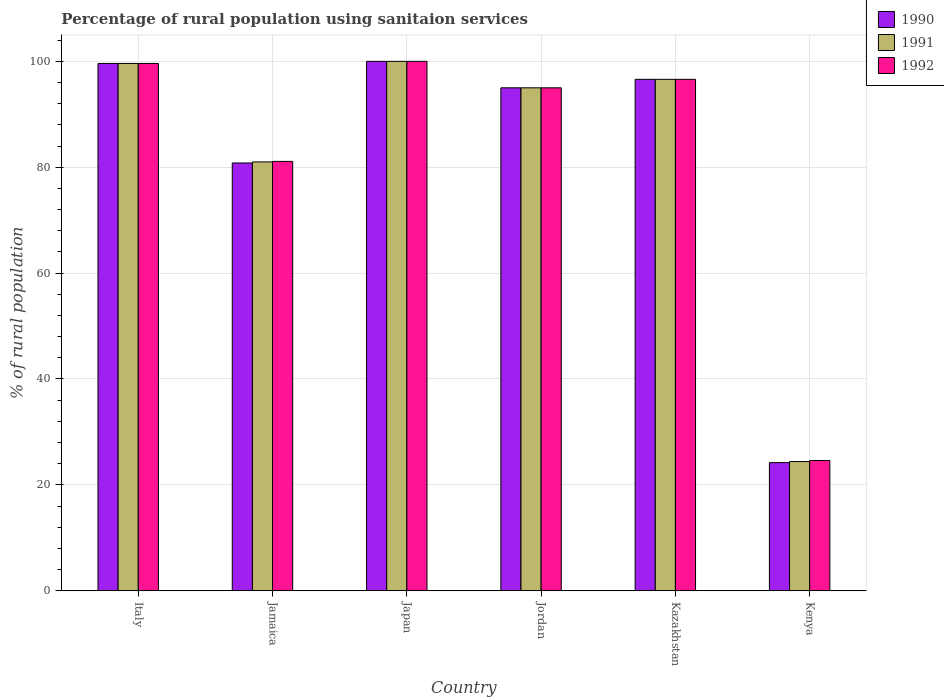How many different coloured bars are there?
Your response must be concise. 3. Are the number of bars per tick equal to the number of legend labels?
Provide a succinct answer. Yes. How many bars are there on the 4th tick from the left?
Your response must be concise. 3. How many bars are there on the 3rd tick from the right?
Provide a short and direct response. 3. What is the label of the 5th group of bars from the left?
Make the answer very short. Kazakhstan. In how many cases, is the number of bars for a given country not equal to the number of legend labels?
Ensure brevity in your answer.  0. What is the percentage of rural population using sanitaion services in 1991 in Kazakhstan?
Offer a very short reply. 96.6. Across all countries, what is the maximum percentage of rural population using sanitaion services in 1990?
Your answer should be very brief. 100. Across all countries, what is the minimum percentage of rural population using sanitaion services in 1991?
Offer a very short reply. 24.4. In which country was the percentage of rural population using sanitaion services in 1991 minimum?
Ensure brevity in your answer.  Kenya. What is the total percentage of rural population using sanitaion services in 1990 in the graph?
Offer a very short reply. 496.2. What is the difference between the percentage of rural population using sanitaion services in 1992 in Jordan and that in Kenya?
Offer a very short reply. 70.4. What is the difference between the percentage of rural population using sanitaion services in 1992 in Italy and the percentage of rural population using sanitaion services in 1990 in Japan?
Keep it short and to the point. -0.4. What is the average percentage of rural population using sanitaion services in 1990 per country?
Your answer should be compact. 82.7. What is the difference between the percentage of rural population using sanitaion services of/in 1991 and percentage of rural population using sanitaion services of/in 1990 in Japan?
Your answer should be very brief. 0. What is the ratio of the percentage of rural population using sanitaion services in 1990 in Italy to that in Kenya?
Offer a terse response. 4.12. What is the difference between the highest and the second highest percentage of rural population using sanitaion services in 1992?
Offer a very short reply. -3. What is the difference between the highest and the lowest percentage of rural population using sanitaion services in 1990?
Ensure brevity in your answer.  75.8. Is the sum of the percentage of rural population using sanitaion services in 1990 in Japan and Kazakhstan greater than the maximum percentage of rural population using sanitaion services in 1991 across all countries?
Keep it short and to the point. Yes. What does the 2nd bar from the left in Jamaica represents?
Keep it short and to the point. 1991. How many bars are there?
Provide a short and direct response. 18. Are all the bars in the graph horizontal?
Provide a short and direct response. No. What is the difference between two consecutive major ticks on the Y-axis?
Your answer should be compact. 20. Does the graph contain any zero values?
Make the answer very short. No. Where does the legend appear in the graph?
Your response must be concise. Top right. What is the title of the graph?
Make the answer very short. Percentage of rural population using sanitaion services. What is the label or title of the X-axis?
Your answer should be very brief. Country. What is the label or title of the Y-axis?
Make the answer very short. % of rural population. What is the % of rural population in 1990 in Italy?
Give a very brief answer. 99.6. What is the % of rural population in 1991 in Italy?
Keep it short and to the point. 99.6. What is the % of rural population of 1992 in Italy?
Provide a short and direct response. 99.6. What is the % of rural population of 1990 in Jamaica?
Offer a terse response. 80.8. What is the % of rural population in 1991 in Jamaica?
Your answer should be very brief. 81. What is the % of rural population in 1992 in Jamaica?
Your answer should be very brief. 81.1. What is the % of rural population in 1991 in Japan?
Your response must be concise. 100. What is the % of rural population in 1991 in Jordan?
Keep it short and to the point. 95. What is the % of rural population in 1990 in Kazakhstan?
Your answer should be compact. 96.6. What is the % of rural population in 1991 in Kazakhstan?
Keep it short and to the point. 96.6. What is the % of rural population in 1992 in Kazakhstan?
Make the answer very short. 96.6. What is the % of rural population of 1990 in Kenya?
Ensure brevity in your answer.  24.2. What is the % of rural population of 1991 in Kenya?
Make the answer very short. 24.4. What is the % of rural population in 1992 in Kenya?
Make the answer very short. 24.6. Across all countries, what is the maximum % of rural population of 1991?
Provide a short and direct response. 100. Across all countries, what is the minimum % of rural population in 1990?
Make the answer very short. 24.2. Across all countries, what is the minimum % of rural population of 1991?
Make the answer very short. 24.4. Across all countries, what is the minimum % of rural population in 1992?
Keep it short and to the point. 24.6. What is the total % of rural population in 1990 in the graph?
Offer a terse response. 496.2. What is the total % of rural population of 1991 in the graph?
Give a very brief answer. 496.6. What is the total % of rural population in 1992 in the graph?
Keep it short and to the point. 496.9. What is the difference between the % of rural population of 1991 in Italy and that in Jamaica?
Your answer should be very brief. 18.6. What is the difference between the % of rural population in 1991 in Italy and that in Japan?
Your response must be concise. -0.4. What is the difference between the % of rural population of 1992 in Italy and that in Japan?
Offer a very short reply. -0.4. What is the difference between the % of rural population of 1992 in Italy and that in Jordan?
Ensure brevity in your answer.  4.6. What is the difference between the % of rural population in 1992 in Italy and that in Kazakhstan?
Provide a short and direct response. 3. What is the difference between the % of rural population of 1990 in Italy and that in Kenya?
Your answer should be very brief. 75.4. What is the difference between the % of rural population of 1991 in Italy and that in Kenya?
Ensure brevity in your answer.  75.2. What is the difference between the % of rural population in 1990 in Jamaica and that in Japan?
Offer a terse response. -19.2. What is the difference between the % of rural population in 1991 in Jamaica and that in Japan?
Provide a succinct answer. -19. What is the difference between the % of rural population in 1992 in Jamaica and that in Japan?
Provide a short and direct response. -18.9. What is the difference between the % of rural population in 1990 in Jamaica and that in Kazakhstan?
Your answer should be compact. -15.8. What is the difference between the % of rural population of 1991 in Jamaica and that in Kazakhstan?
Your answer should be compact. -15.6. What is the difference between the % of rural population in 1992 in Jamaica and that in Kazakhstan?
Make the answer very short. -15.5. What is the difference between the % of rural population in 1990 in Jamaica and that in Kenya?
Keep it short and to the point. 56.6. What is the difference between the % of rural population of 1991 in Jamaica and that in Kenya?
Give a very brief answer. 56.6. What is the difference between the % of rural population of 1992 in Jamaica and that in Kenya?
Your answer should be compact. 56.5. What is the difference between the % of rural population in 1990 in Japan and that in Jordan?
Make the answer very short. 5. What is the difference between the % of rural population of 1992 in Japan and that in Jordan?
Offer a terse response. 5. What is the difference between the % of rural population in 1991 in Japan and that in Kazakhstan?
Give a very brief answer. 3.4. What is the difference between the % of rural population in 1990 in Japan and that in Kenya?
Your response must be concise. 75.8. What is the difference between the % of rural population in 1991 in Japan and that in Kenya?
Keep it short and to the point. 75.6. What is the difference between the % of rural population of 1992 in Japan and that in Kenya?
Provide a succinct answer. 75.4. What is the difference between the % of rural population of 1990 in Jordan and that in Kazakhstan?
Provide a succinct answer. -1.6. What is the difference between the % of rural population in 1991 in Jordan and that in Kazakhstan?
Offer a terse response. -1.6. What is the difference between the % of rural population in 1990 in Jordan and that in Kenya?
Provide a succinct answer. 70.8. What is the difference between the % of rural population of 1991 in Jordan and that in Kenya?
Provide a succinct answer. 70.6. What is the difference between the % of rural population in 1992 in Jordan and that in Kenya?
Ensure brevity in your answer.  70.4. What is the difference between the % of rural population of 1990 in Kazakhstan and that in Kenya?
Offer a terse response. 72.4. What is the difference between the % of rural population in 1991 in Kazakhstan and that in Kenya?
Keep it short and to the point. 72.2. What is the difference between the % of rural population in 1990 in Italy and the % of rural population in 1991 in Jamaica?
Your answer should be compact. 18.6. What is the difference between the % of rural population in 1990 in Italy and the % of rural population in 1992 in Jamaica?
Offer a terse response. 18.5. What is the difference between the % of rural population of 1990 in Italy and the % of rural population of 1991 in Japan?
Ensure brevity in your answer.  -0.4. What is the difference between the % of rural population in 1990 in Italy and the % of rural population in 1991 in Jordan?
Ensure brevity in your answer.  4.6. What is the difference between the % of rural population of 1990 in Italy and the % of rural population of 1992 in Jordan?
Give a very brief answer. 4.6. What is the difference between the % of rural population of 1990 in Italy and the % of rural population of 1991 in Kazakhstan?
Your answer should be compact. 3. What is the difference between the % of rural population in 1990 in Italy and the % of rural population in 1991 in Kenya?
Your answer should be very brief. 75.2. What is the difference between the % of rural population of 1990 in Jamaica and the % of rural population of 1991 in Japan?
Make the answer very short. -19.2. What is the difference between the % of rural population of 1990 in Jamaica and the % of rural population of 1992 in Japan?
Your response must be concise. -19.2. What is the difference between the % of rural population in 1990 in Jamaica and the % of rural population in 1991 in Jordan?
Your response must be concise. -14.2. What is the difference between the % of rural population in 1990 in Jamaica and the % of rural population in 1992 in Jordan?
Ensure brevity in your answer.  -14.2. What is the difference between the % of rural population of 1991 in Jamaica and the % of rural population of 1992 in Jordan?
Your answer should be very brief. -14. What is the difference between the % of rural population in 1990 in Jamaica and the % of rural population in 1991 in Kazakhstan?
Provide a succinct answer. -15.8. What is the difference between the % of rural population in 1990 in Jamaica and the % of rural population in 1992 in Kazakhstan?
Offer a very short reply. -15.8. What is the difference between the % of rural population in 1991 in Jamaica and the % of rural population in 1992 in Kazakhstan?
Provide a short and direct response. -15.6. What is the difference between the % of rural population of 1990 in Jamaica and the % of rural population of 1991 in Kenya?
Provide a succinct answer. 56.4. What is the difference between the % of rural population of 1990 in Jamaica and the % of rural population of 1992 in Kenya?
Your response must be concise. 56.2. What is the difference between the % of rural population of 1991 in Jamaica and the % of rural population of 1992 in Kenya?
Keep it short and to the point. 56.4. What is the difference between the % of rural population in 1990 in Japan and the % of rural population in 1992 in Jordan?
Your answer should be compact. 5. What is the difference between the % of rural population of 1990 in Japan and the % of rural population of 1992 in Kazakhstan?
Provide a succinct answer. 3.4. What is the difference between the % of rural population of 1990 in Japan and the % of rural population of 1991 in Kenya?
Ensure brevity in your answer.  75.6. What is the difference between the % of rural population in 1990 in Japan and the % of rural population in 1992 in Kenya?
Your response must be concise. 75.4. What is the difference between the % of rural population of 1991 in Japan and the % of rural population of 1992 in Kenya?
Give a very brief answer. 75.4. What is the difference between the % of rural population in 1990 in Jordan and the % of rural population in 1991 in Kazakhstan?
Offer a very short reply. -1.6. What is the difference between the % of rural population of 1990 in Jordan and the % of rural population of 1992 in Kazakhstan?
Make the answer very short. -1.6. What is the difference between the % of rural population of 1990 in Jordan and the % of rural population of 1991 in Kenya?
Provide a short and direct response. 70.6. What is the difference between the % of rural population of 1990 in Jordan and the % of rural population of 1992 in Kenya?
Keep it short and to the point. 70.4. What is the difference between the % of rural population of 1991 in Jordan and the % of rural population of 1992 in Kenya?
Provide a short and direct response. 70.4. What is the difference between the % of rural population of 1990 in Kazakhstan and the % of rural population of 1991 in Kenya?
Provide a succinct answer. 72.2. What is the difference between the % of rural population of 1990 in Kazakhstan and the % of rural population of 1992 in Kenya?
Ensure brevity in your answer.  72. What is the average % of rural population of 1990 per country?
Your response must be concise. 82.7. What is the average % of rural population in 1991 per country?
Your answer should be very brief. 82.77. What is the average % of rural population of 1992 per country?
Offer a very short reply. 82.82. What is the difference between the % of rural population of 1990 and % of rural population of 1991 in Italy?
Offer a very short reply. 0. What is the difference between the % of rural population in 1990 and % of rural population in 1992 in Jamaica?
Offer a very short reply. -0.3. What is the difference between the % of rural population of 1991 and % of rural population of 1992 in Jamaica?
Your response must be concise. -0.1. What is the difference between the % of rural population in 1990 and % of rural population in 1991 in Japan?
Your answer should be compact. 0. What is the difference between the % of rural population in 1990 and % of rural population in 1991 in Jordan?
Keep it short and to the point. 0. What is the difference between the % of rural population of 1990 and % of rural population of 1991 in Kazakhstan?
Ensure brevity in your answer.  0. What is the difference between the % of rural population in 1990 and % of rural population in 1991 in Kenya?
Ensure brevity in your answer.  -0.2. What is the difference between the % of rural population of 1990 and % of rural population of 1992 in Kenya?
Your response must be concise. -0.4. What is the difference between the % of rural population in 1991 and % of rural population in 1992 in Kenya?
Make the answer very short. -0.2. What is the ratio of the % of rural population of 1990 in Italy to that in Jamaica?
Make the answer very short. 1.23. What is the ratio of the % of rural population in 1991 in Italy to that in Jamaica?
Keep it short and to the point. 1.23. What is the ratio of the % of rural population of 1992 in Italy to that in Jamaica?
Keep it short and to the point. 1.23. What is the ratio of the % of rural population of 1990 in Italy to that in Jordan?
Your answer should be very brief. 1.05. What is the ratio of the % of rural population of 1991 in Italy to that in Jordan?
Offer a terse response. 1.05. What is the ratio of the % of rural population of 1992 in Italy to that in Jordan?
Give a very brief answer. 1.05. What is the ratio of the % of rural population in 1990 in Italy to that in Kazakhstan?
Keep it short and to the point. 1.03. What is the ratio of the % of rural population of 1991 in Italy to that in Kazakhstan?
Offer a very short reply. 1.03. What is the ratio of the % of rural population in 1992 in Italy to that in Kazakhstan?
Keep it short and to the point. 1.03. What is the ratio of the % of rural population of 1990 in Italy to that in Kenya?
Offer a terse response. 4.12. What is the ratio of the % of rural population of 1991 in Italy to that in Kenya?
Keep it short and to the point. 4.08. What is the ratio of the % of rural population in 1992 in Italy to that in Kenya?
Ensure brevity in your answer.  4.05. What is the ratio of the % of rural population of 1990 in Jamaica to that in Japan?
Provide a short and direct response. 0.81. What is the ratio of the % of rural population of 1991 in Jamaica to that in Japan?
Offer a terse response. 0.81. What is the ratio of the % of rural population in 1992 in Jamaica to that in Japan?
Your answer should be compact. 0.81. What is the ratio of the % of rural population in 1990 in Jamaica to that in Jordan?
Make the answer very short. 0.85. What is the ratio of the % of rural population of 1991 in Jamaica to that in Jordan?
Make the answer very short. 0.85. What is the ratio of the % of rural population in 1992 in Jamaica to that in Jordan?
Make the answer very short. 0.85. What is the ratio of the % of rural population in 1990 in Jamaica to that in Kazakhstan?
Make the answer very short. 0.84. What is the ratio of the % of rural population in 1991 in Jamaica to that in Kazakhstan?
Your response must be concise. 0.84. What is the ratio of the % of rural population of 1992 in Jamaica to that in Kazakhstan?
Give a very brief answer. 0.84. What is the ratio of the % of rural population in 1990 in Jamaica to that in Kenya?
Provide a short and direct response. 3.34. What is the ratio of the % of rural population in 1991 in Jamaica to that in Kenya?
Your answer should be very brief. 3.32. What is the ratio of the % of rural population of 1992 in Jamaica to that in Kenya?
Ensure brevity in your answer.  3.3. What is the ratio of the % of rural population in 1990 in Japan to that in Jordan?
Give a very brief answer. 1.05. What is the ratio of the % of rural population in 1991 in Japan to that in Jordan?
Offer a terse response. 1.05. What is the ratio of the % of rural population in 1992 in Japan to that in Jordan?
Offer a terse response. 1.05. What is the ratio of the % of rural population of 1990 in Japan to that in Kazakhstan?
Offer a very short reply. 1.04. What is the ratio of the % of rural population of 1991 in Japan to that in Kazakhstan?
Keep it short and to the point. 1.04. What is the ratio of the % of rural population of 1992 in Japan to that in Kazakhstan?
Give a very brief answer. 1.04. What is the ratio of the % of rural population in 1990 in Japan to that in Kenya?
Offer a terse response. 4.13. What is the ratio of the % of rural population of 1991 in Japan to that in Kenya?
Offer a terse response. 4.1. What is the ratio of the % of rural population of 1992 in Japan to that in Kenya?
Ensure brevity in your answer.  4.07. What is the ratio of the % of rural population of 1990 in Jordan to that in Kazakhstan?
Offer a terse response. 0.98. What is the ratio of the % of rural population of 1991 in Jordan to that in Kazakhstan?
Offer a terse response. 0.98. What is the ratio of the % of rural population in 1992 in Jordan to that in Kazakhstan?
Provide a succinct answer. 0.98. What is the ratio of the % of rural population in 1990 in Jordan to that in Kenya?
Offer a terse response. 3.93. What is the ratio of the % of rural population in 1991 in Jordan to that in Kenya?
Keep it short and to the point. 3.89. What is the ratio of the % of rural population of 1992 in Jordan to that in Kenya?
Your answer should be very brief. 3.86. What is the ratio of the % of rural population in 1990 in Kazakhstan to that in Kenya?
Provide a succinct answer. 3.99. What is the ratio of the % of rural population of 1991 in Kazakhstan to that in Kenya?
Make the answer very short. 3.96. What is the ratio of the % of rural population in 1992 in Kazakhstan to that in Kenya?
Offer a very short reply. 3.93. What is the difference between the highest and the second highest % of rural population in 1990?
Offer a terse response. 0.4. What is the difference between the highest and the second highest % of rural population in 1991?
Your response must be concise. 0.4. What is the difference between the highest and the second highest % of rural population in 1992?
Your answer should be very brief. 0.4. What is the difference between the highest and the lowest % of rural population of 1990?
Your answer should be very brief. 75.8. What is the difference between the highest and the lowest % of rural population in 1991?
Give a very brief answer. 75.6. What is the difference between the highest and the lowest % of rural population in 1992?
Your answer should be compact. 75.4. 